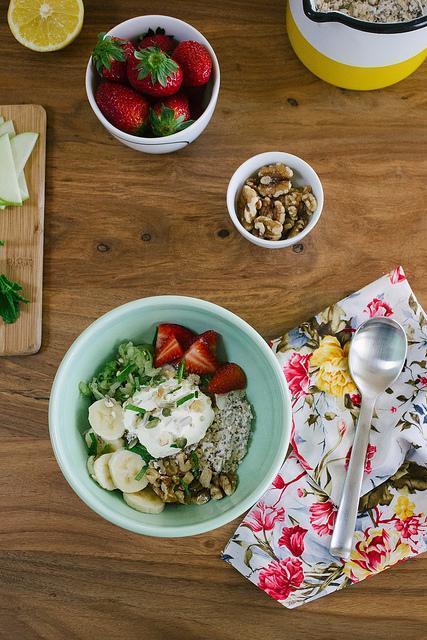How many bowls are in the picture?
Give a very brief answer. 3. 